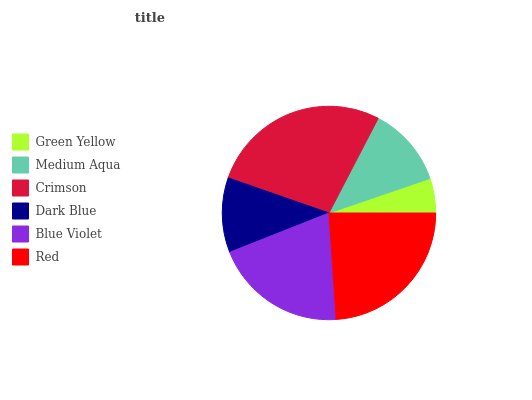Is Green Yellow the minimum?
Answer yes or no. Yes. Is Crimson the maximum?
Answer yes or no. Yes. Is Medium Aqua the minimum?
Answer yes or no. No. Is Medium Aqua the maximum?
Answer yes or no. No. Is Medium Aqua greater than Green Yellow?
Answer yes or no. Yes. Is Green Yellow less than Medium Aqua?
Answer yes or no. Yes. Is Green Yellow greater than Medium Aqua?
Answer yes or no. No. Is Medium Aqua less than Green Yellow?
Answer yes or no. No. Is Blue Violet the high median?
Answer yes or no. Yes. Is Medium Aqua the low median?
Answer yes or no. Yes. Is Medium Aqua the high median?
Answer yes or no. No. Is Red the low median?
Answer yes or no. No. 